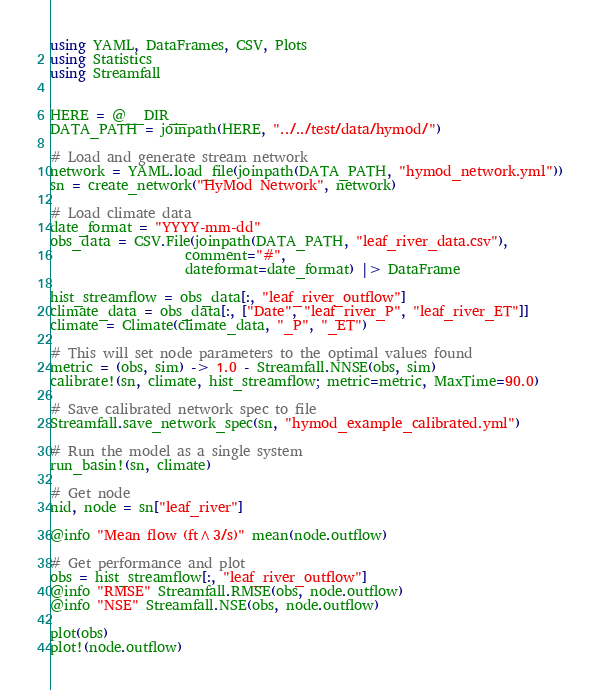Convert code to text. <code><loc_0><loc_0><loc_500><loc_500><_Julia_>using YAML, DataFrames, CSV, Plots
using Statistics
using Streamfall


HERE = @__DIR__
DATA_PATH = joinpath(HERE, "../../test/data/hymod/")

# Load and generate stream network
network = YAML.load_file(joinpath(DATA_PATH, "hymod_network.yml"))
sn = create_network("HyMod Network", network)

# Load climate data
date_format = "YYYY-mm-dd"
obs_data = CSV.File(joinpath(DATA_PATH, "leaf_river_data.csv"),
                    comment="#",
                    dateformat=date_format) |> DataFrame

hist_streamflow = obs_data[:, "leaf_river_outflow"]
climate_data = obs_data[:, ["Date", "leaf_river_P", "leaf_river_ET"]]
climate = Climate(climate_data, "_P", "_ET")

# This will set node parameters to the optimal values found
metric = (obs, sim) -> 1.0 - Streamfall.NNSE(obs, sim)
calibrate!(sn, climate, hist_streamflow; metric=metric, MaxTime=90.0)

# Save calibrated network spec to file
Streamfall.save_network_spec(sn, "hymod_example_calibrated.yml")

# Run the model as a single system
run_basin!(sn, climate)

# Get node
nid, node = sn["leaf_river"]

@info "Mean flow (ft^3/s)" mean(node.outflow)

# Get performance and plot
obs = hist_streamflow[:, "leaf_river_outflow"]
@info "RMSE" Streamfall.RMSE(obs, node.outflow)
@info "NSE" Streamfall.NSE(obs, node.outflow)

plot(obs)
plot!(node.outflow)

</code> 